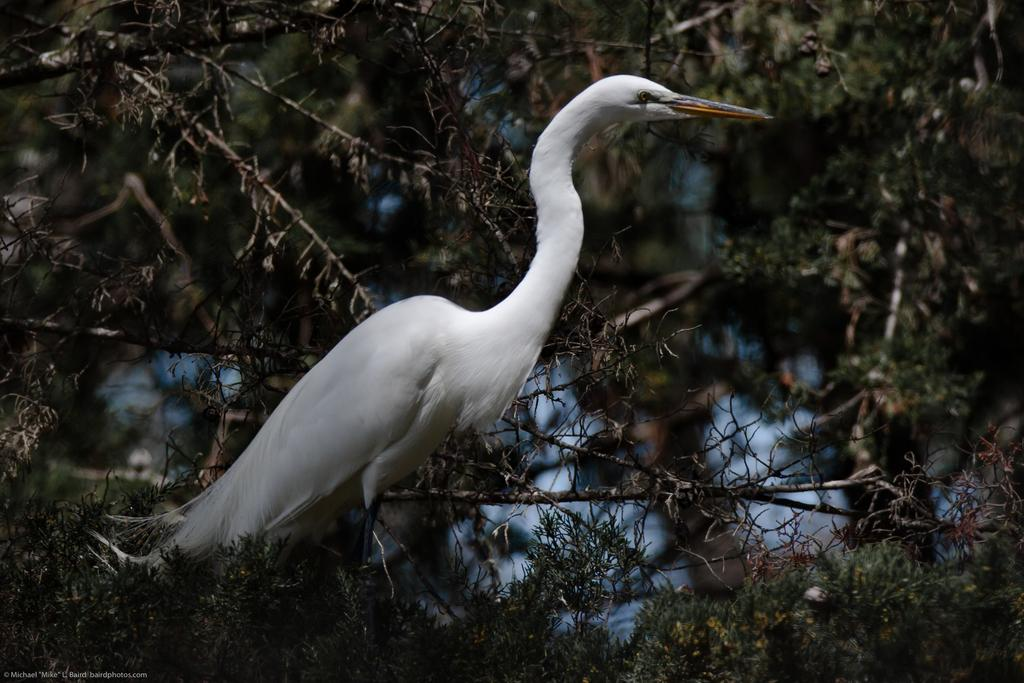What type of bird is present in the image? There is a white color crane in the image. What can be seen in the background of the image? There are trees in the background of the image. Where is the watermark located in the image? The watermark is on the left side of the image. What type of book is the laborer reading on this sunny day? There is no book, laborer, or mention of a sunny day in the image. 